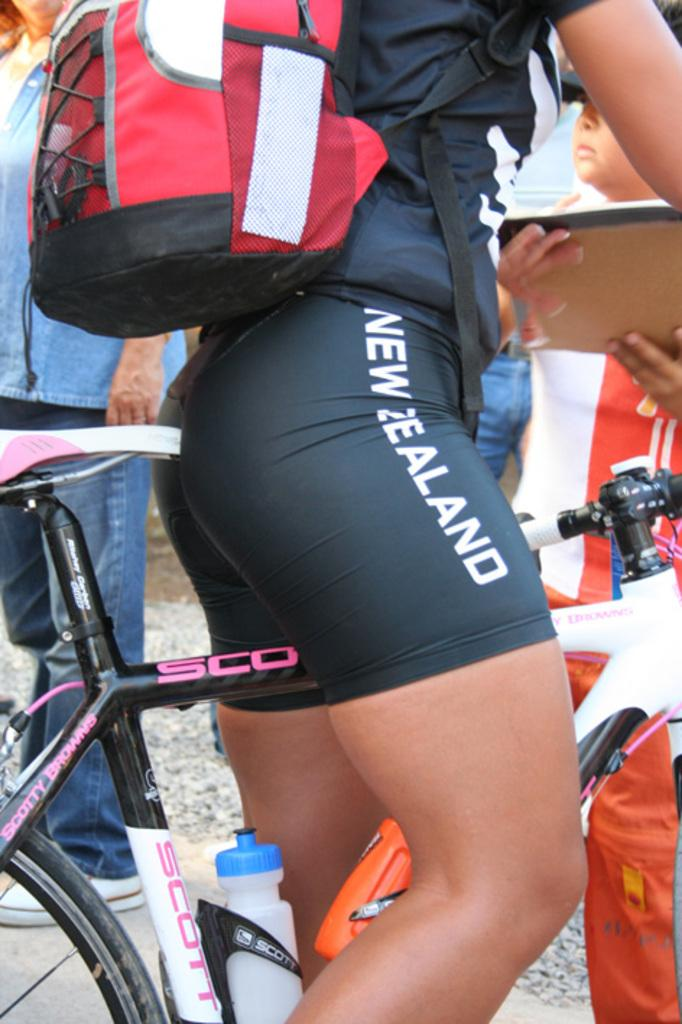What is the main subject of the image? There is a person in the image. What is the person doing in the image? The person is sitting on a bicycle. What color combination is the person wearing? The person is wearing a black and white shirt. What type of bottom clothing is the person wearing? The person is wearing shorts. What accessory is the person carrying in the image? The person has a backpack. What colors are visible on the backpack? The backpack is in red, black, and white colors. What type of straw is the person using to drink in the image? There is no straw visible in the image; the person is sitting on a bicycle and wearing a backpack. 